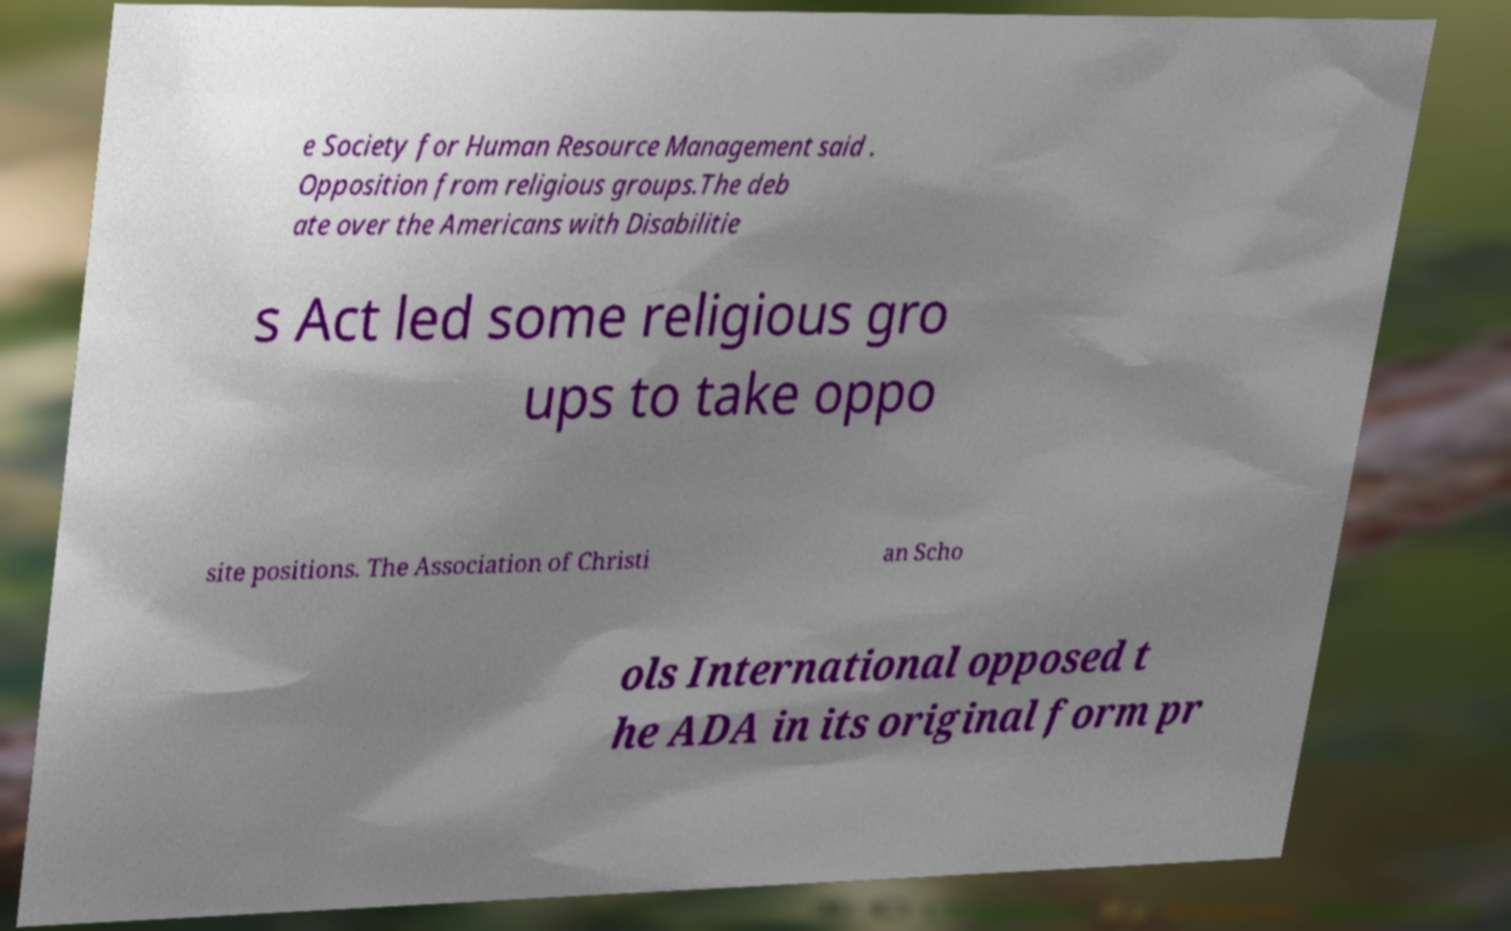What messages or text are displayed in this image? I need them in a readable, typed format. e Society for Human Resource Management said . Opposition from religious groups.The deb ate over the Americans with Disabilitie s Act led some religious gro ups to take oppo site positions. The Association of Christi an Scho ols International opposed t he ADA in its original form pr 